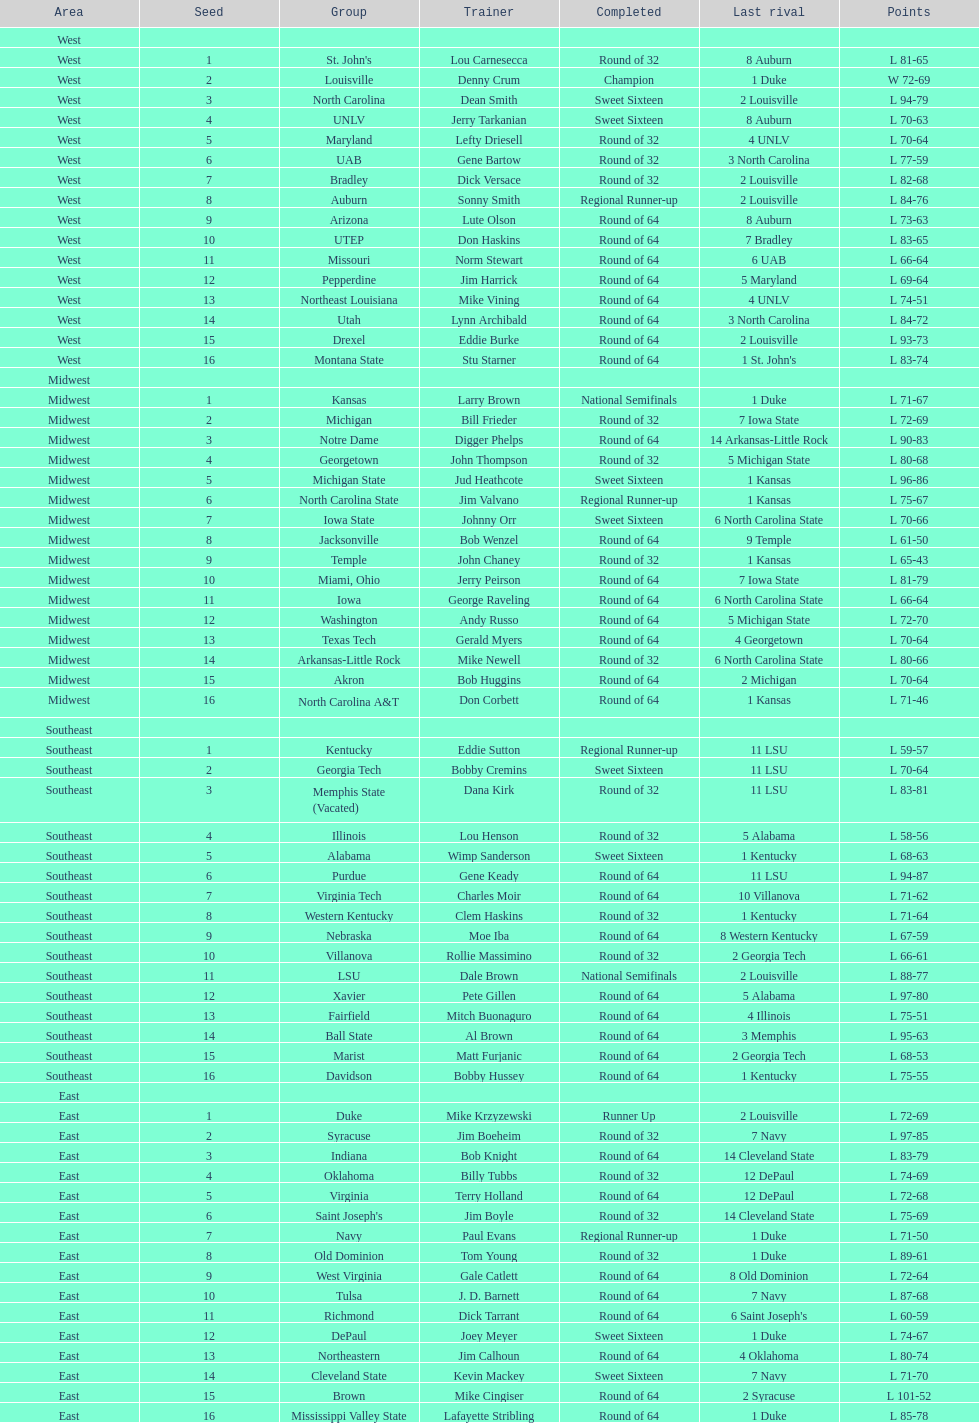Which is the sole team from the east region to attain the final round? Duke. I'm looking to parse the entire table for insights. Could you assist me with that? {'header': ['Area', 'Seed', 'Group', 'Trainer', 'Completed', 'Last rival', 'Points'], 'rows': [['West', '', '', '', '', '', ''], ['West', '1', "St. John's", 'Lou Carnesecca', 'Round of 32', '8 Auburn', 'L 81-65'], ['West', '2', 'Louisville', 'Denny Crum', 'Champion', '1 Duke', 'W 72-69'], ['West', '3', 'North Carolina', 'Dean Smith', 'Sweet Sixteen', '2 Louisville', 'L 94-79'], ['West', '4', 'UNLV', 'Jerry Tarkanian', 'Sweet Sixteen', '8 Auburn', 'L 70-63'], ['West', '5', 'Maryland', 'Lefty Driesell', 'Round of 32', '4 UNLV', 'L 70-64'], ['West', '6', 'UAB', 'Gene Bartow', 'Round of 32', '3 North Carolina', 'L 77-59'], ['West', '7', 'Bradley', 'Dick Versace', 'Round of 32', '2 Louisville', 'L 82-68'], ['West', '8', 'Auburn', 'Sonny Smith', 'Regional Runner-up', '2 Louisville', 'L 84-76'], ['West', '9', 'Arizona', 'Lute Olson', 'Round of 64', '8 Auburn', 'L 73-63'], ['West', '10', 'UTEP', 'Don Haskins', 'Round of 64', '7 Bradley', 'L 83-65'], ['West', '11', 'Missouri', 'Norm Stewart', 'Round of 64', '6 UAB', 'L 66-64'], ['West', '12', 'Pepperdine', 'Jim Harrick', 'Round of 64', '5 Maryland', 'L 69-64'], ['West', '13', 'Northeast Louisiana', 'Mike Vining', 'Round of 64', '4 UNLV', 'L 74-51'], ['West', '14', 'Utah', 'Lynn Archibald', 'Round of 64', '3 North Carolina', 'L 84-72'], ['West', '15', 'Drexel', 'Eddie Burke', 'Round of 64', '2 Louisville', 'L 93-73'], ['West', '16', 'Montana State', 'Stu Starner', 'Round of 64', "1 St. John's", 'L 83-74'], ['Midwest', '', '', '', '', '', ''], ['Midwest', '1', 'Kansas', 'Larry Brown', 'National Semifinals', '1 Duke', 'L 71-67'], ['Midwest', '2', 'Michigan', 'Bill Frieder', 'Round of 32', '7 Iowa State', 'L 72-69'], ['Midwest', '3', 'Notre Dame', 'Digger Phelps', 'Round of 64', '14 Arkansas-Little Rock', 'L 90-83'], ['Midwest', '4', 'Georgetown', 'John Thompson', 'Round of 32', '5 Michigan State', 'L 80-68'], ['Midwest', '5', 'Michigan State', 'Jud Heathcote', 'Sweet Sixteen', '1 Kansas', 'L 96-86'], ['Midwest', '6', 'North Carolina State', 'Jim Valvano', 'Regional Runner-up', '1 Kansas', 'L 75-67'], ['Midwest', '7', 'Iowa State', 'Johnny Orr', 'Sweet Sixteen', '6 North Carolina State', 'L 70-66'], ['Midwest', '8', 'Jacksonville', 'Bob Wenzel', 'Round of 64', '9 Temple', 'L 61-50'], ['Midwest', '9', 'Temple', 'John Chaney', 'Round of 32', '1 Kansas', 'L 65-43'], ['Midwest', '10', 'Miami, Ohio', 'Jerry Peirson', 'Round of 64', '7 Iowa State', 'L 81-79'], ['Midwest', '11', 'Iowa', 'George Raveling', 'Round of 64', '6 North Carolina State', 'L 66-64'], ['Midwest', '12', 'Washington', 'Andy Russo', 'Round of 64', '5 Michigan State', 'L 72-70'], ['Midwest', '13', 'Texas Tech', 'Gerald Myers', 'Round of 64', '4 Georgetown', 'L 70-64'], ['Midwest', '14', 'Arkansas-Little Rock', 'Mike Newell', 'Round of 32', '6 North Carolina State', 'L 80-66'], ['Midwest', '15', 'Akron', 'Bob Huggins', 'Round of 64', '2 Michigan', 'L 70-64'], ['Midwest', '16', 'North Carolina A&T', 'Don Corbett', 'Round of 64', '1 Kansas', 'L 71-46'], ['Southeast', '', '', '', '', '', ''], ['Southeast', '1', 'Kentucky', 'Eddie Sutton', 'Regional Runner-up', '11 LSU', 'L 59-57'], ['Southeast', '2', 'Georgia Tech', 'Bobby Cremins', 'Sweet Sixteen', '11 LSU', 'L 70-64'], ['Southeast', '3', 'Memphis State (Vacated)', 'Dana Kirk', 'Round of 32', '11 LSU', 'L 83-81'], ['Southeast', '4', 'Illinois', 'Lou Henson', 'Round of 32', '5 Alabama', 'L 58-56'], ['Southeast', '5', 'Alabama', 'Wimp Sanderson', 'Sweet Sixteen', '1 Kentucky', 'L 68-63'], ['Southeast', '6', 'Purdue', 'Gene Keady', 'Round of 64', '11 LSU', 'L 94-87'], ['Southeast', '7', 'Virginia Tech', 'Charles Moir', 'Round of 64', '10 Villanova', 'L 71-62'], ['Southeast', '8', 'Western Kentucky', 'Clem Haskins', 'Round of 32', '1 Kentucky', 'L 71-64'], ['Southeast', '9', 'Nebraska', 'Moe Iba', 'Round of 64', '8 Western Kentucky', 'L 67-59'], ['Southeast', '10', 'Villanova', 'Rollie Massimino', 'Round of 32', '2 Georgia Tech', 'L 66-61'], ['Southeast', '11', 'LSU', 'Dale Brown', 'National Semifinals', '2 Louisville', 'L 88-77'], ['Southeast', '12', 'Xavier', 'Pete Gillen', 'Round of 64', '5 Alabama', 'L 97-80'], ['Southeast', '13', 'Fairfield', 'Mitch Buonaguro', 'Round of 64', '4 Illinois', 'L 75-51'], ['Southeast', '14', 'Ball State', 'Al Brown', 'Round of 64', '3 Memphis', 'L 95-63'], ['Southeast', '15', 'Marist', 'Matt Furjanic', 'Round of 64', '2 Georgia Tech', 'L 68-53'], ['Southeast', '16', 'Davidson', 'Bobby Hussey', 'Round of 64', '1 Kentucky', 'L 75-55'], ['East', '', '', '', '', '', ''], ['East', '1', 'Duke', 'Mike Krzyzewski', 'Runner Up', '2 Louisville', 'L 72-69'], ['East', '2', 'Syracuse', 'Jim Boeheim', 'Round of 32', '7 Navy', 'L 97-85'], ['East', '3', 'Indiana', 'Bob Knight', 'Round of 64', '14 Cleveland State', 'L 83-79'], ['East', '4', 'Oklahoma', 'Billy Tubbs', 'Round of 32', '12 DePaul', 'L 74-69'], ['East', '5', 'Virginia', 'Terry Holland', 'Round of 64', '12 DePaul', 'L 72-68'], ['East', '6', "Saint Joseph's", 'Jim Boyle', 'Round of 32', '14 Cleveland State', 'L 75-69'], ['East', '7', 'Navy', 'Paul Evans', 'Regional Runner-up', '1 Duke', 'L 71-50'], ['East', '8', 'Old Dominion', 'Tom Young', 'Round of 32', '1 Duke', 'L 89-61'], ['East', '9', 'West Virginia', 'Gale Catlett', 'Round of 64', '8 Old Dominion', 'L 72-64'], ['East', '10', 'Tulsa', 'J. D. Barnett', 'Round of 64', '7 Navy', 'L 87-68'], ['East', '11', 'Richmond', 'Dick Tarrant', 'Round of 64', "6 Saint Joseph's", 'L 60-59'], ['East', '12', 'DePaul', 'Joey Meyer', 'Sweet Sixteen', '1 Duke', 'L 74-67'], ['East', '13', 'Northeastern', 'Jim Calhoun', 'Round of 64', '4 Oklahoma', 'L 80-74'], ['East', '14', 'Cleveland State', 'Kevin Mackey', 'Sweet Sixteen', '7 Navy', 'L 71-70'], ['East', '15', 'Brown', 'Mike Cingiser', 'Round of 64', '2 Syracuse', 'L 101-52'], ['East', '16', 'Mississippi Valley State', 'Lafayette Stribling', 'Round of 64', '1 Duke', 'L 85-78']]} 